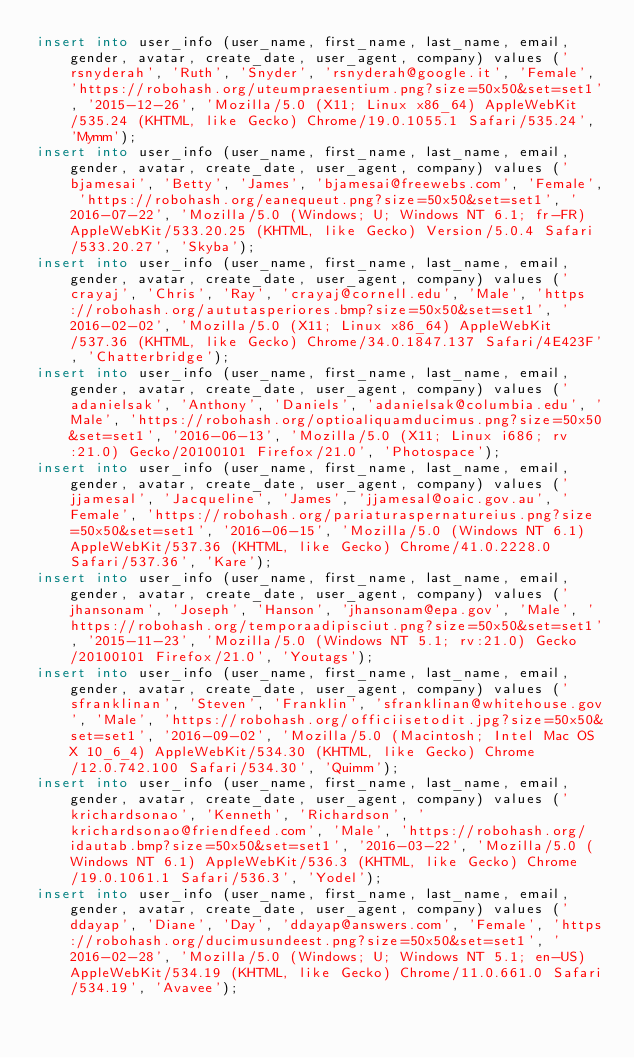Convert code to text. <code><loc_0><loc_0><loc_500><loc_500><_SQL_>insert into user_info (user_name, first_name, last_name, email, gender, avatar, create_date, user_agent, company) values ('rsnyderah', 'Ruth', 'Snyder', 'rsnyderah@google.it', 'Female', 'https://robohash.org/uteumpraesentium.png?size=50x50&set=set1', '2015-12-26', 'Mozilla/5.0 (X11; Linux x86_64) AppleWebKit/535.24 (KHTML, like Gecko) Chrome/19.0.1055.1 Safari/535.24', 'Mymm');
insert into user_info (user_name, first_name, last_name, email, gender, avatar, create_date, user_agent, company) values ('bjamesai', 'Betty', 'James', 'bjamesai@freewebs.com', 'Female', 'https://robohash.org/eanequeut.png?size=50x50&set=set1', '2016-07-22', 'Mozilla/5.0 (Windows; U; Windows NT 6.1; fr-FR) AppleWebKit/533.20.25 (KHTML, like Gecko) Version/5.0.4 Safari/533.20.27', 'Skyba');
insert into user_info (user_name, first_name, last_name, email, gender, avatar, create_date, user_agent, company) values ('crayaj', 'Chris', 'Ray', 'crayaj@cornell.edu', 'Male', 'https://robohash.org/aututasperiores.bmp?size=50x50&set=set1', '2016-02-02', 'Mozilla/5.0 (X11; Linux x86_64) AppleWebKit/537.36 (KHTML, like Gecko) Chrome/34.0.1847.137 Safari/4E423F', 'Chatterbridge');
insert into user_info (user_name, first_name, last_name, email, gender, avatar, create_date, user_agent, company) values ('adanielsak', 'Anthony', 'Daniels', 'adanielsak@columbia.edu', 'Male', 'https://robohash.org/optioaliquamducimus.png?size=50x50&set=set1', '2016-06-13', 'Mozilla/5.0 (X11; Linux i686; rv:21.0) Gecko/20100101 Firefox/21.0', 'Photospace');
insert into user_info (user_name, first_name, last_name, email, gender, avatar, create_date, user_agent, company) values ('jjamesal', 'Jacqueline', 'James', 'jjamesal@oaic.gov.au', 'Female', 'https://robohash.org/pariaturaspernatureius.png?size=50x50&set=set1', '2016-06-15', 'Mozilla/5.0 (Windows NT 6.1) AppleWebKit/537.36 (KHTML, like Gecko) Chrome/41.0.2228.0 Safari/537.36', 'Kare');
insert into user_info (user_name, first_name, last_name, email, gender, avatar, create_date, user_agent, company) values ('jhansonam', 'Joseph', 'Hanson', 'jhansonam@epa.gov', 'Male', 'https://robohash.org/temporaadipisciut.png?size=50x50&set=set1', '2015-11-23', 'Mozilla/5.0 (Windows NT 5.1; rv:21.0) Gecko/20100101 Firefox/21.0', 'Youtags');
insert into user_info (user_name, first_name, last_name, email, gender, avatar, create_date, user_agent, company) values ('sfranklinan', 'Steven', 'Franklin', 'sfranklinan@whitehouse.gov', 'Male', 'https://robohash.org/officiisetodit.jpg?size=50x50&set=set1', '2016-09-02', 'Mozilla/5.0 (Macintosh; Intel Mac OS X 10_6_4) AppleWebKit/534.30 (KHTML, like Gecko) Chrome/12.0.742.100 Safari/534.30', 'Quimm');
insert into user_info (user_name, first_name, last_name, email, gender, avatar, create_date, user_agent, company) values ('krichardsonao', 'Kenneth', 'Richardson', 'krichardsonao@friendfeed.com', 'Male', 'https://robohash.org/idautab.bmp?size=50x50&set=set1', '2016-03-22', 'Mozilla/5.0 (Windows NT 6.1) AppleWebKit/536.3 (KHTML, like Gecko) Chrome/19.0.1061.1 Safari/536.3', 'Yodel');
insert into user_info (user_name, first_name, last_name, email, gender, avatar, create_date, user_agent, company) values ('ddayap', 'Diane', 'Day', 'ddayap@answers.com', 'Female', 'https://robohash.org/ducimusundeest.png?size=50x50&set=set1', '2016-02-28', 'Mozilla/5.0 (Windows; U; Windows NT 5.1; en-US) AppleWebKit/534.19 (KHTML, like Gecko) Chrome/11.0.661.0 Safari/534.19', 'Avavee');</code> 